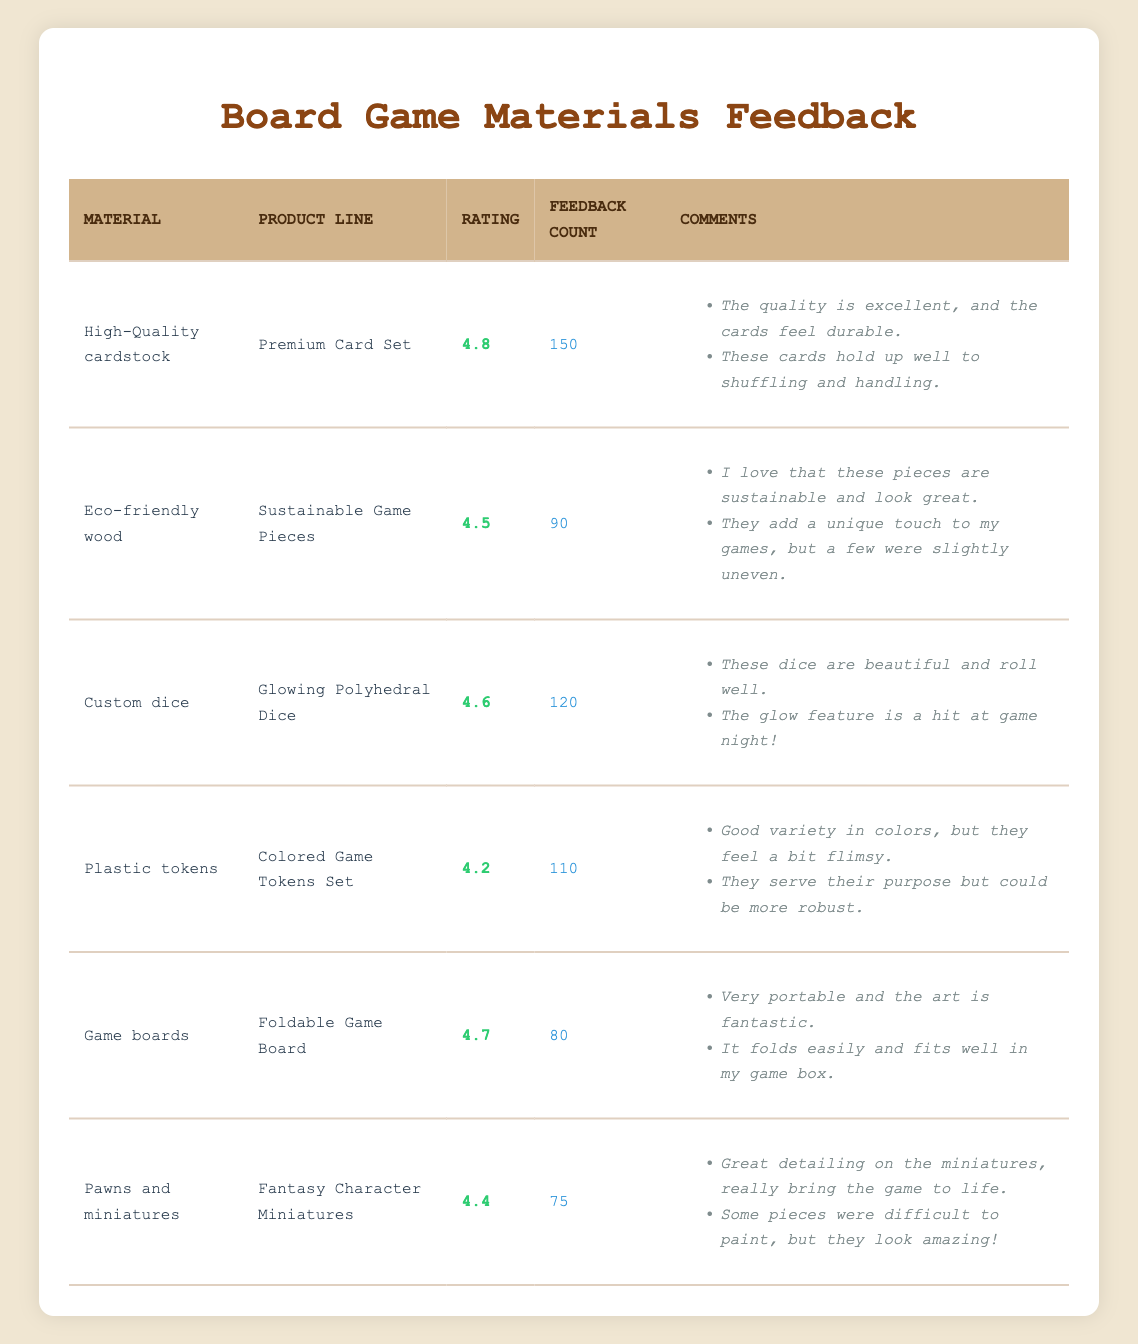What is the highest customer rating among the materials? The highest customer rating reported in the table is 4.8, corresponding to the "High-Quality cardstock" under the "Premium Card Set" product line.
Answer: 4.8 How many feedback comments were provided for the Eco-friendly wood product line? The feedback count for the "Eco-friendly wood" product line is 90, meaning there were a total of 90 feedback comments for this material.
Answer: 90 Which board game material has the lowest customer rating, and what is that rating? The material with the lowest customer rating is "Plastic tokens," which has a rating of 4.2.
Answer: 4.2 What is the average customer rating of the materials listed? To compute the average, we sum the ratings: (4.8 + 4.5 + 4.6 + 4.2 + 4.7 + 4.4) = 27.2. There are 6 materials, so the average rating is 27.2 / 6 = 4.53.
Answer: 4.53 Do more customers provided feedback on Custom dice compared to Pawns and miniatures? Yes, "Custom dice" received feedback from 120 customers, while "Pawns and miniatures" received feedback from 75 customers, indicating more feedback for Custom dice.
Answer: Yes Which product line has a feedback count of 80? The product line with a feedback count of 80 is "Foldable Game Board," which corresponds to the material "Game boards."
Answer: Foldable Game Board Is the customer rating for Eco-friendly wood higher than that for Pawns and miniatures? Yes, Eco-friendly wood has a customer rating of 4.5, while Pawns and miniatures have a rating of 4.4, making Eco-friendly wood's rating higher.
Answer: Yes What is the difference in the feedback count between High-Quality cardstock and Plastic tokens? The feedback count for "High-Quality cardstock" is 150, while for "Plastic tokens," it is 110. The difference is 150 - 110 = 40.
Answer: 40 Which material has the most feedback comments, and how many comments does it have? The material with the most feedback comments is "High-Quality cardstock" with a feedback count of 150 comments.
Answer: 150 